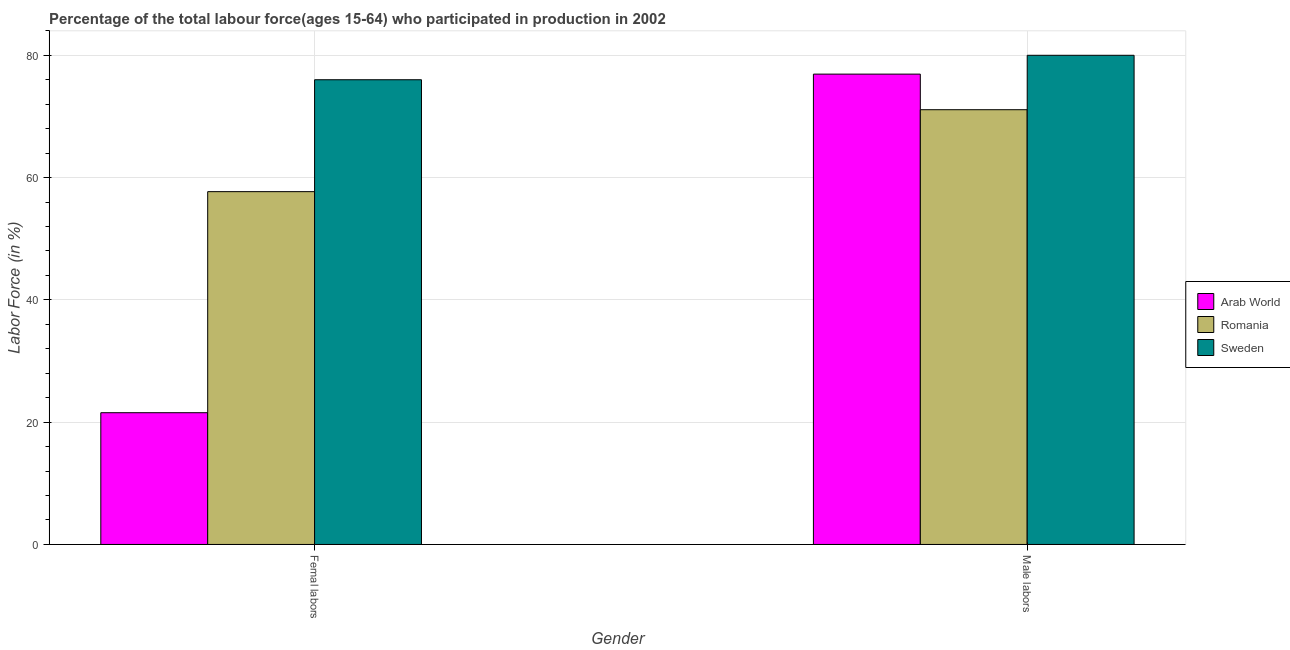How many different coloured bars are there?
Make the answer very short. 3. How many bars are there on the 1st tick from the left?
Provide a succinct answer. 3. What is the label of the 1st group of bars from the left?
Your response must be concise. Femal labors. What is the percentage of female labor force in Arab World?
Offer a terse response. 21.55. Across all countries, what is the minimum percentage of female labor force?
Offer a terse response. 21.55. In which country was the percentage of male labour force minimum?
Keep it short and to the point. Romania. What is the total percentage of female labor force in the graph?
Your answer should be very brief. 155.25. What is the difference between the percentage of female labor force in Sweden and that in Arab World?
Give a very brief answer. 54.45. What is the difference between the percentage of male labour force in Sweden and the percentage of female labor force in Arab World?
Provide a succinct answer. 58.45. What is the average percentage of female labor force per country?
Offer a very short reply. 51.75. What is the ratio of the percentage of male labour force in Arab World to that in Romania?
Provide a short and direct response. 1.08. Is the percentage of female labor force in Romania less than that in Sweden?
Ensure brevity in your answer.  Yes. What does the 1st bar from the left in Femal labors represents?
Make the answer very short. Arab World. How many countries are there in the graph?
Ensure brevity in your answer.  3. Are the values on the major ticks of Y-axis written in scientific E-notation?
Ensure brevity in your answer.  No. Does the graph contain any zero values?
Make the answer very short. No. Does the graph contain grids?
Provide a short and direct response. Yes. How many legend labels are there?
Provide a short and direct response. 3. How are the legend labels stacked?
Provide a succinct answer. Vertical. What is the title of the graph?
Your response must be concise. Percentage of the total labour force(ages 15-64) who participated in production in 2002. Does "High income" appear as one of the legend labels in the graph?
Offer a terse response. No. What is the label or title of the Y-axis?
Ensure brevity in your answer.  Labor Force (in %). What is the Labor Force (in %) in Arab World in Femal labors?
Provide a succinct answer. 21.55. What is the Labor Force (in %) of Romania in Femal labors?
Offer a very short reply. 57.7. What is the Labor Force (in %) in Arab World in Male labors?
Offer a terse response. 76.92. What is the Labor Force (in %) of Romania in Male labors?
Your response must be concise. 71.1. Across all Gender, what is the maximum Labor Force (in %) in Arab World?
Your answer should be very brief. 76.92. Across all Gender, what is the maximum Labor Force (in %) of Romania?
Your response must be concise. 71.1. Across all Gender, what is the maximum Labor Force (in %) in Sweden?
Provide a short and direct response. 80. Across all Gender, what is the minimum Labor Force (in %) in Arab World?
Offer a terse response. 21.55. Across all Gender, what is the minimum Labor Force (in %) of Romania?
Your response must be concise. 57.7. Across all Gender, what is the minimum Labor Force (in %) of Sweden?
Provide a succinct answer. 76. What is the total Labor Force (in %) in Arab World in the graph?
Your answer should be compact. 98.47. What is the total Labor Force (in %) in Romania in the graph?
Offer a terse response. 128.8. What is the total Labor Force (in %) of Sweden in the graph?
Ensure brevity in your answer.  156. What is the difference between the Labor Force (in %) in Arab World in Femal labors and that in Male labors?
Make the answer very short. -55.38. What is the difference between the Labor Force (in %) of Sweden in Femal labors and that in Male labors?
Provide a succinct answer. -4. What is the difference between the Labor Force (in %) of Arab World in Femal labors and the Labor Force (in %) of Romania in Male labors?
Your answer should be very brief. -49.55. What is the difference between the Labor Force (in %) of Arab World in Femal labors and the Labor Force (in %) of Sweden in Male labors?
Your answer should be compact. -58.45. What is the difference between the Labor Force (in %) in Romania in Femal labors and the Labor Force (in %) in Sweden in Male labors?
Provide a succinct answer. -22.3. What is the average Labor Force (in %) in Arab World per Gender?
Give a very brief answer. 49.23. What is the average Labor Force (in %) in Romania per Gender?
Offer a very short reply. 64.4. What is the average Labor Force (in %) in Sweden per Gender?
Ensure brevity in your answer.  78. What is the difference between the Labor Force (in %) in Arab World and Labor Force (in %) in Romania in Femal labors?
Give a very brief answer. -36.16. What is the difference between the Labor Force (in %) of Arab World and Labor Force (in %) of Sweden in Femal labors?
Your response must be concise. -54.45. What is the difference between the Labor Force (in %) in Romania and Labor Force (in %) in Sweden in Femal labors?
Your answer should be very brief. -18.3. What is the difference between the Labor Force (in %) in Arab World and Labor Force (in %) in Romania in Male labors?
Your answer should be compact. 5.82. What is the difference between the Labor Force (in %) in Arab World and Labor Force (in %) in Sweden in Male labors?
Provide a short and direct response. -3.08. What is the difference between the Labor Force (in %) of Romania and Labor Force (in %) of Sweden in Male labors?
Your answer should be compact. -8.9. What is the ratio of the Labor Force (in %) of Arab World in Femal labors to that in Male labors?
Offer a very short reply. 0.28. What is the ratio of the Labor Force (in %) of Romania in Femal labors to that in Male labors?
Make the answer very short. 0.81. What is the ratio of the Labor Force (in %) of Sweden in Femal labors to that in Male labors?
Give a very brief answer. 0.95. What is the difference between the highest and the second highest Labor Force (in %) in Arab World?
Your answer should be very brief. 55.38. What is the difference between the highest and the second highest Labor Force (in %) of Romania?
Provide a succinct answer. 13.4. What is the difference between the highest and the second highest Labor Force (in %) in Sweden?
Your response must be concise. 4. What is the difference between the highest and the lowest Labor Force (in %) of Arab World?
Your answer should be very brief. 55.38. What is the difference between the highest and the lowest Labor Force (in %) of Sweden?
Your response must be concise. 4. 